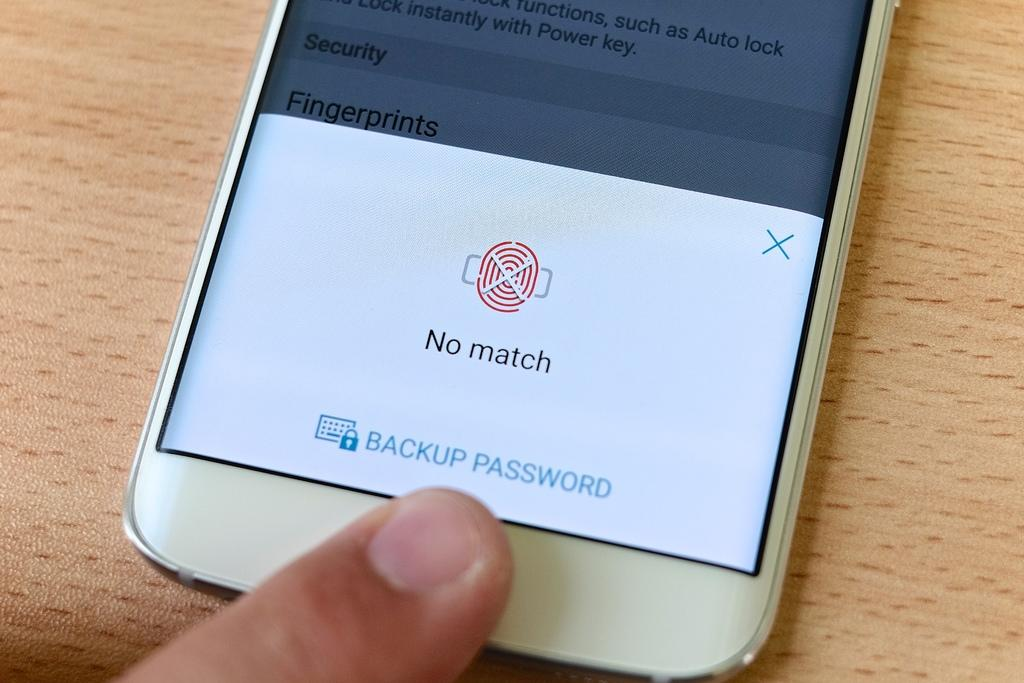<image>
Render a clear and concise summary of the photo. A cell phone displaying a "no match" fingerprints message 